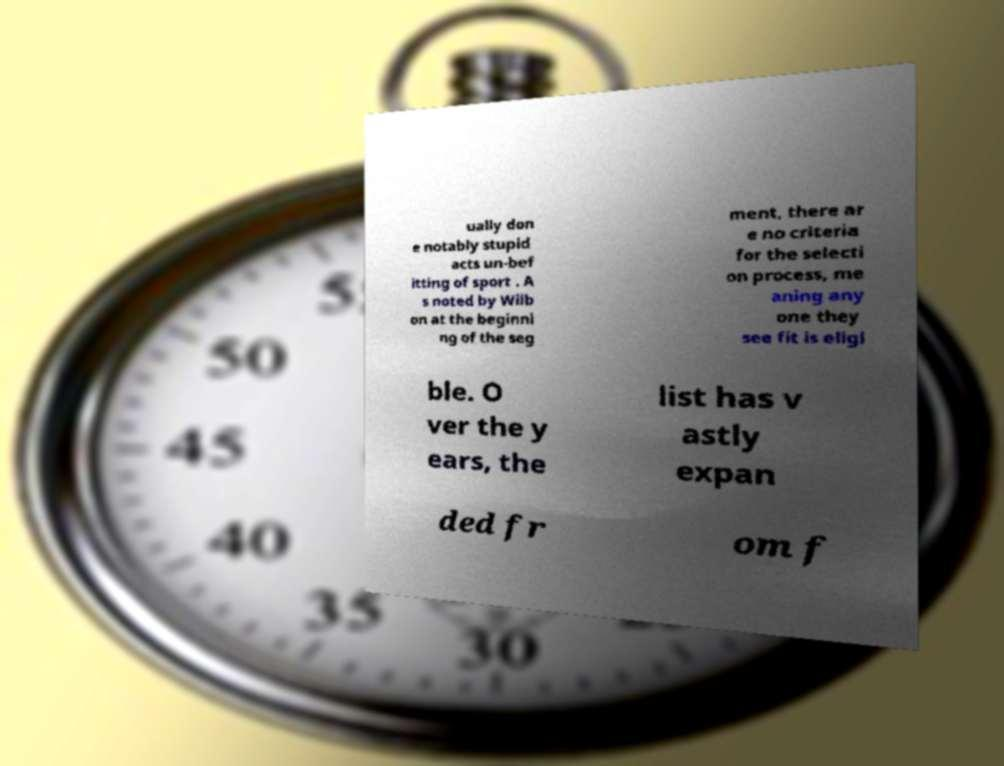There's text embedded in this image that I need extracted. Can you transcribe it verbatim? ually don e notably stupid acts un-bef itting of sport . A s noted by Wilb on at the beginni ng of the seg ment, there ar e no criteria for the selecti on process, me aning any one they see fit is eligi ble. O ver the y ears, the list has v astly expan ded fr om f 